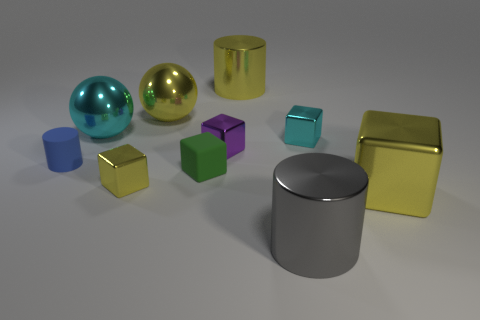How would you describe the texture of the objects? The objects have a smooth and shiny texture, indicative of metallic surfaces, reflecting their surroundings with a high gloss finish. Which one has the least shiny surface? The silver cylinder in the center has the least shiny surface among the objects; its finish is more matte compared to the high gloss of the others. 